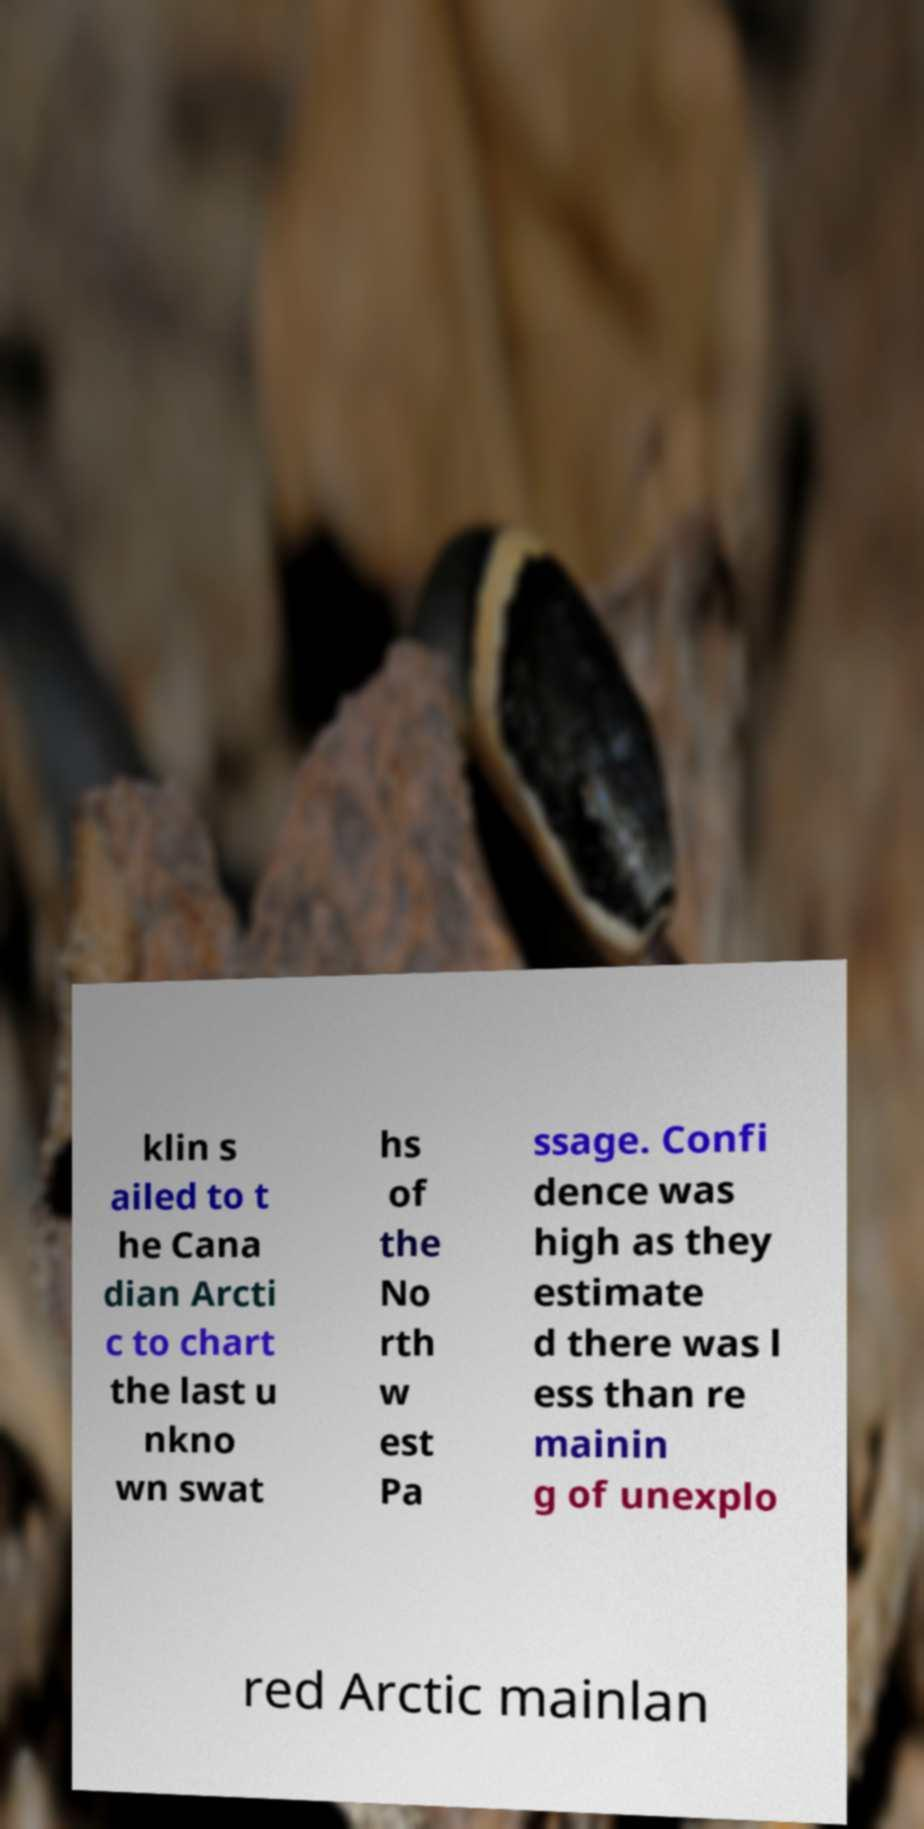What messages or text are displayed in this image? I need them in a readable, typed format. klin s ailed to t he Cana dian Arcti c to chart the last u nkno wn swat hs of the No rth w est Pa ssage. Confi dence was high as they estimate d there was l ess than re mainin g of unexplo red Arctic mainlan 